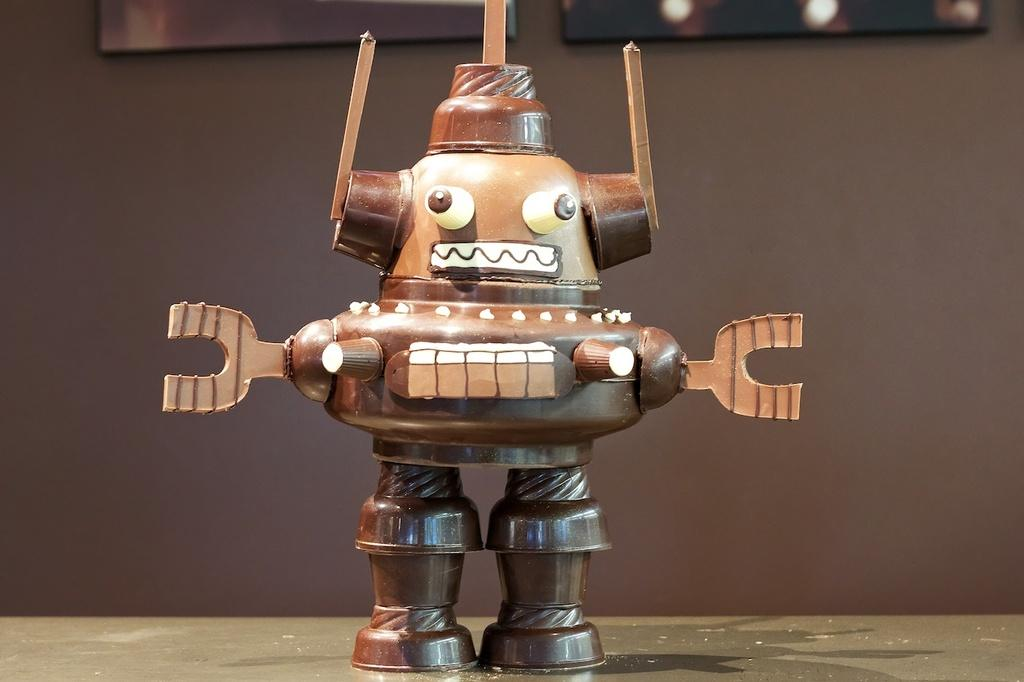What is the color of the object or item in the image? The object or item in the image is brown-colored. How many hands are visible on the brown-colored object in the image? There are no hands visible on the brown-colored object in the image, as it is not a living being or an object with hands. 